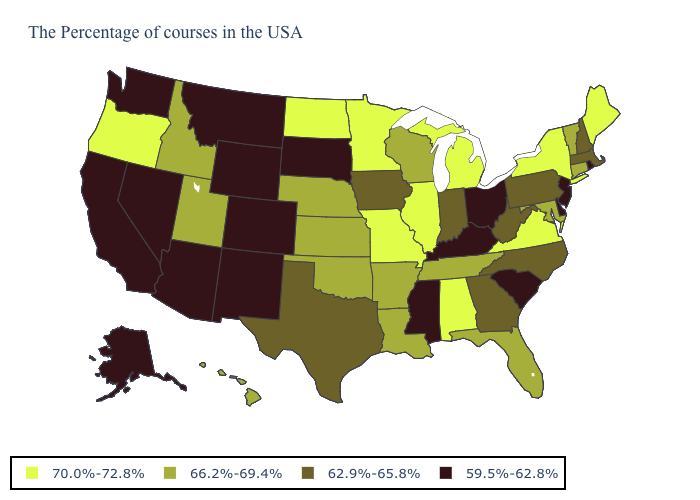Among the states that border Alabama , which have the highest value?
Answer briefly. Florida, Tennessee. What is the highest value in the West ?
Short answer required. 70.0%-72.8%. Is the legend a continuous bar?
Write a very short answer. No. Which states have the lowest value in the MidWest?
Be succinct. Ohio, South Dakota. What is the value of Alaska?
Keep it brief. 59.5%-62.8%. Does Massachusetts have a higher value than Iowa?
Give a very brief answer. No. Name the states that have a value in the range 70.0%-72.8%?
Short answer required. Maine, New York, Virginia, Michigan, Alabama, Illinois, Missouri, Minnesota, North Dakota, Oregon. Does South Dakota have a lower value than Alaska?
Write a very short answer. No. What is the highest value in the USA?
Give a very brief answer. 70.0%-72.8%. What is the value of Louisiana?
Be succinct. 66.2%-69.4%. Name the states that have a value in the range 59.5%-62.8%?
Quick response, please. Rhode Island, New Jersey, Delaware, South Carolina, Ohio, Kentucky, Mississippi, South Dakota, Wyoming, Colorado, New Mexico, Montana, Arizona, Nevada, California, Washington, Alaska. Does Texas have the highest value in the USA?
Answer briefly. No. What is the highest value in states that border Connecticut?
Keep it brief. 70.0%-72.8%. Does the first symbol in the legend represent the smallest category?
Answer briefly. No. What is the highest value in the West ?
Short answer required. 70.0%-72.8%. 